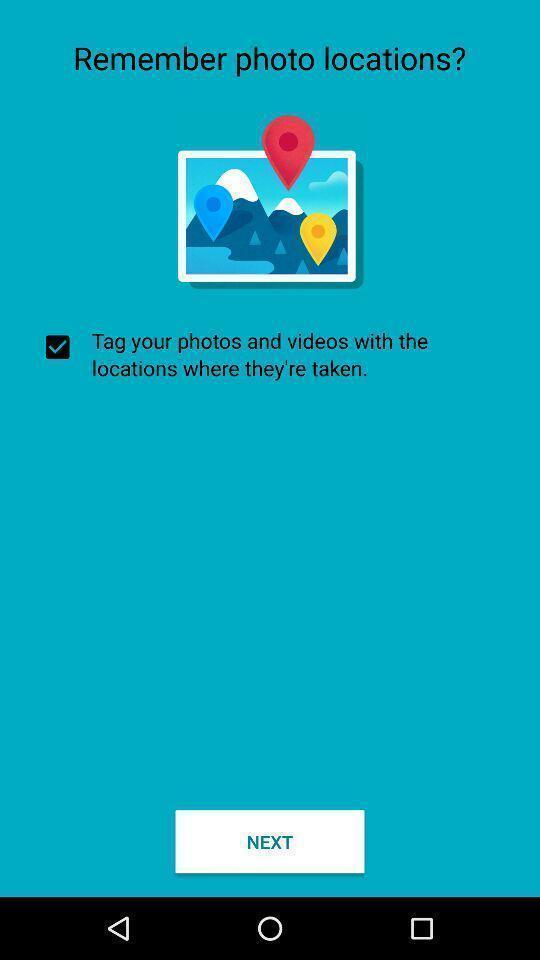Tell me what you see in this picture. Screen shows to know the location of photos. Describe this image in words. Screen showing remember photo locations. 